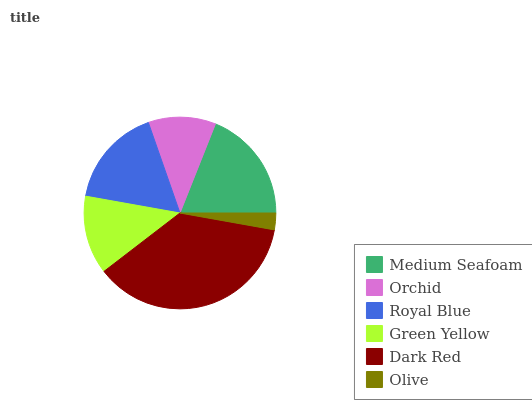Is Olive the minimum?
Answer yes or no. Yes. Is Dark Red the maximum?
Answer yes or no. Yes. Is Orchid the minimum?
Answer yes or no. No. Is Orchid the maximum?
Answer yes or no. No. Is Medium Seafoam greater than Orchid?
Answer yes or no. Yes. Is Orchid less than Medium Seafoam?
Answer yes or no. Yes. Is Orchid greater than Medium Seafoam?
Answer yes or no. No. Is Medium Seafoam less than Orchid?
Answer yes or no. No. Is Royal Blue the high median?
Answer yes or no. Yes. Is Green Yellow the low median?
Answer yes or no. Yes. Is Medium Seafoam the high median?
Answer yes or no. No. Is Medium Seafoam the low median?
Answer yes or no. No. 